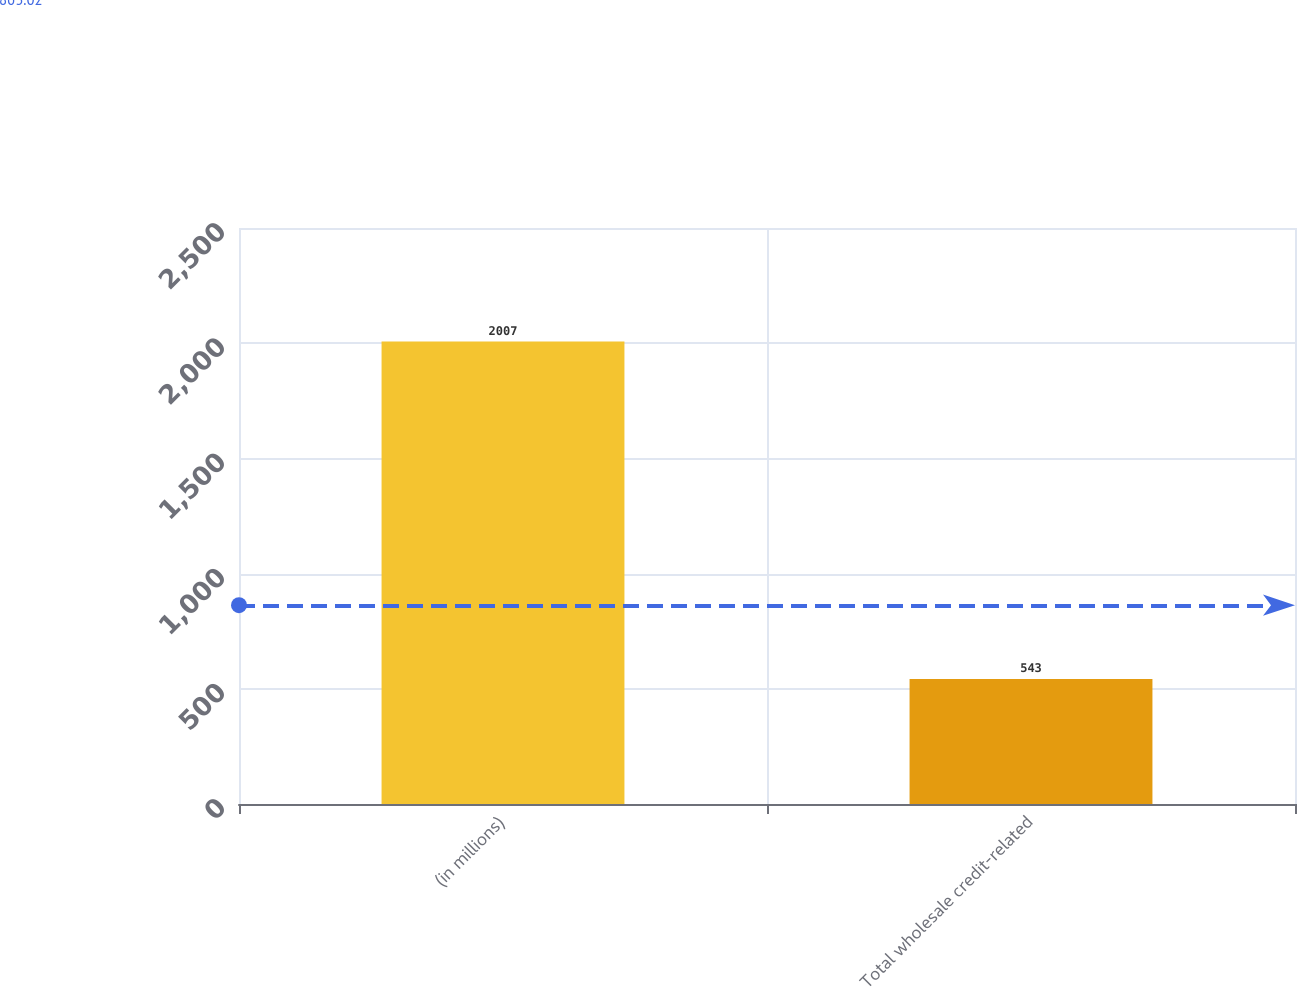Convert chart to OTSL. <chart><loc_0><loc_0><loc_500><loc_500><bar_chart><fcel>(in millions)<fcel>Total wholesale credit-related<nl><fcel>2007<fcel>543<nl></chart> 